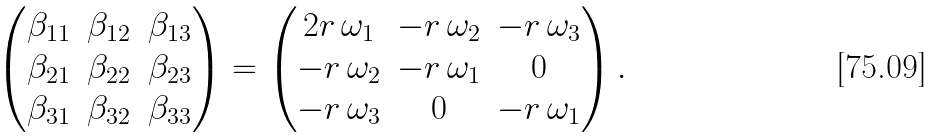<formula> <loc_0><loc_0><loc_500><loc_500>\begin{pmatrix} \beta _ { 1 1 } & \beta _ { 1 2 } & \beta _ { 1 3 } \\ \beta _ { 2 1 } & \beta _ { 2 2 } & \beta _ { 2 3 } \\ \beta _ { 3 1 } & \beta _ { 3 2 } & \beta _ { 3 3 } \end{pmatrix} = \begin{pmatrix} 2 r \, \omega _ { 1 } & - r \, \omega _ { 2 } & - r \, \omega _ { 3 } \\ - r \, \omega _ { 2 } & - r \, \omega _ { 1 } & 0 \\ - r \, \omega _ { 3 } & 0 & - r \, \omega _ { 1 } \end{pmatrix} .</formula> 